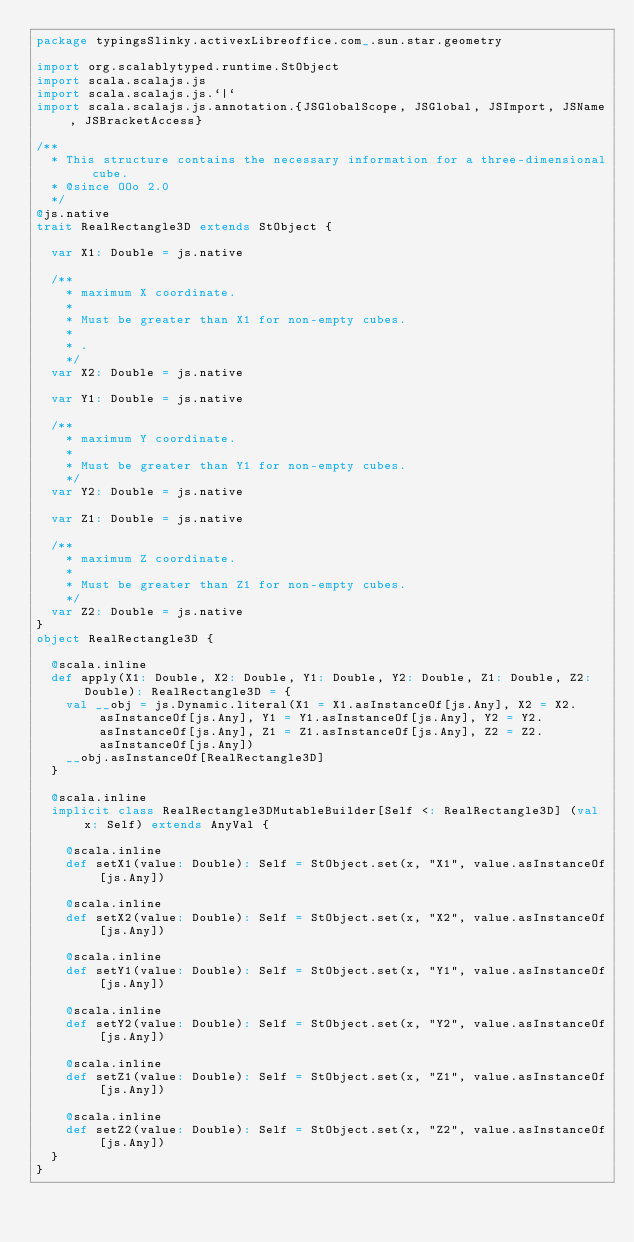Convert code to text. <code><loc_0><loc_0><loc_500><loc_500><_Scala_>package typingsSlinky.activexLibreoffice.com_.sun.star.geometry

import org.scalablytyped.runtime.StObject
import scala.scalajs.js
import scala.scalajs.js.`|`
import scala.scalajs.js.annotation.{JSGlobalScope, JSGlobal, JSImport, JSName, JSBracketAccess}

/**
  * This structure contains the necessary information for a three-dimensional cube.
  * @since OOo 2.0
  */
@js.native
trait RealRectangle3D extends StObject {
  
  var X1: Double = js.native
  
  /**
    * maximum X coordinate.
    *
    * Must be greater than X1 for non-empty cubes.
    *
    * .
    */
  var X2: Double = js.native
  
  var Y1: Double = js.native
  
  /**
    * maximum Y coordinate.
    *
    * Must be greater than Y1 for non-empty cubes.
    */
  var Y2: Double = js.native
  
  var Z1: Double = js.native
  
  /**
    * maximum Z coordinate.
    *
    * Must be greater than Z1 for non-empty cubes.
    */
  var Z2: Double = js.native
}
object RealRectangle3D {
  
  @scala.inline
  def apply(X1: Double, X2: Double, Y1: Double, Y2: Double, Z1: Double, Z2: Double): RealRectangle3D = {
    val __obj = js.Dynamic.literal(X1 = X1.asInstanceOf[js.Any], X2 = X2.asInstanceOf[js.Any], Y1 = Y1.asInstanceOf[js.Any], Y2 = Y2.asInstanceOf[js.Any], Z1 = Z1.asInstanceOf[js.Any], Z2 = Z2.asInstanceOf[js.Any])
    __obj.asInstanceOf[RealRectangle3D]
  }
  
  @scala.inline
  implicit class RealRectangle3DMutableBuilder[Self <: RealRectangle3D] (val x: Self) extends AnyVal {
    
    @scala.inline
    def setX1(value: Double): Self = StObject.set(x, "X1", value.asInstanceOf[js.Any])
    
    @scala.inline
    def setX2(value: Double): Self = StObject.set(x, "X2", value.asInstanceOf[js.Any])
    
    @scala.inline
    def setY1(value: Double): Self = StObject.set(x, "Y1", value.asInstanceOf[js.Any])
    
    @scala.inline
    def setY2(value: Double): Self = StObject.set(x, "Y2", value.asInstanceOf[js.Any])
    
    @scala.inline
    def setZ1(value: Double): Self = StObject.set(x, "Z1", value.asInstanceOf[js.Any])
    
    @scala.inline
    def setZ2(value: Double): Self = StObject.set(x, "Z2", value.asInstanceOf[js.Any])
  }
}
</code> 